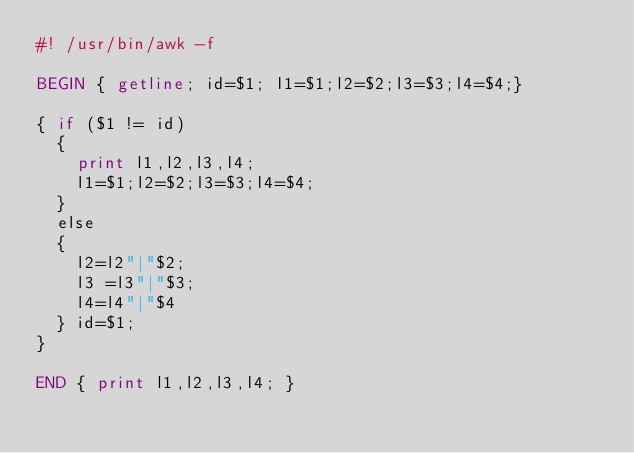<code> <loc_0><loc_0><loc_500><loc_500><_Awk_>#! /usr/bin/awk -f

BEGIN { getline; id=$1; l1=$1;l2=$2;l3=$3;l4=$4;}

{ if ($1 != id)
  {
    print l1,l2,l3,l4;
    l1=$1;l2=$2;l3=$3;l4=$4;
  }
  else
  {
    l2=l2"|"$2;
    l3 =l3"|"$3;
    l4=l4"|"$4
  } id=$1;
}

END { print l1,l2,l3,l4; }
</code> 